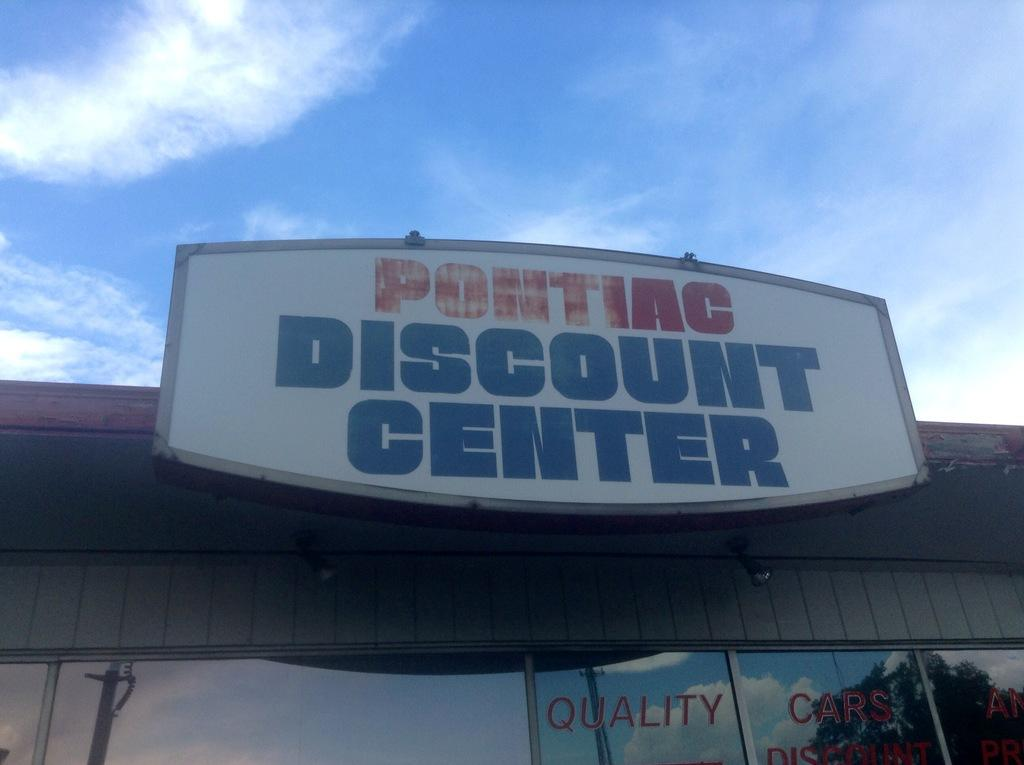Provide a one-sentence caption for the provided image. You can find quality cars at the Pontiac Discount Center. 